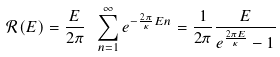<formula> <loc_0><loc_0><loc_500><loc_500>\mathcal { R } ( E ) = \frac { E } { 2 \pi } \ \sum _ { n = 1 } ^ { \infty } e ^ { - \frac { 2 \pi } { \kappa } E n } = \frac { 1 } { 2 \pi } \frac { E } { e ^ { \frac { 2 \pi E } { \kappa } } - 1 }</formula> 